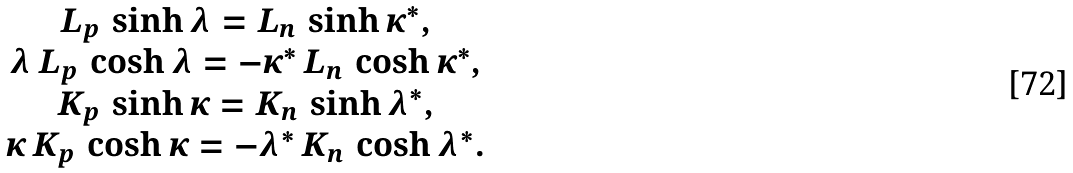<formula> <loc_0><loc_0><loc_500><loc_500>\begin{array} { c } L _ { p } \, \sinh \lambda = L _ { n } \, \sinh \kappa ^ { * } , \\ \lambda \, L _ { p } \, \cosh \lambda = - \kappa ^ { * } \, L _ { n } \, \cosh \kappa ^ { * } , \\ K _ { p } \, \sinh \kappa = K _ { n } \, \sinh \lambda ^ { * } , \\ \kappa \, K _ { p } \, \cosh \kappa = - \lambda ^ { * } \, K _ { n } \, \cosh \lambda ^ { * } . \end{array}</formula> 